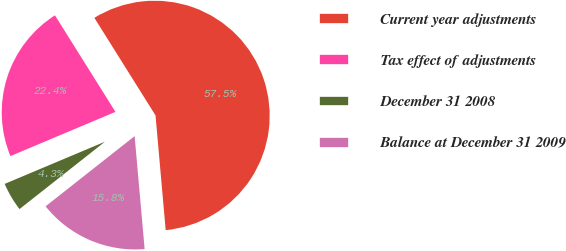<chart> <loc_0><loc_0><loc_500><loc_500><pie_chart><fcel>Current year adjustments<fcel>Tax effect of adjustments<fcel>December 31 2008<fcel>Balance at December 31 2009<nl><fcel>57.51%<fcel>22.43%<fcel>4.29%<fcel>15.78%<nl></chart> 